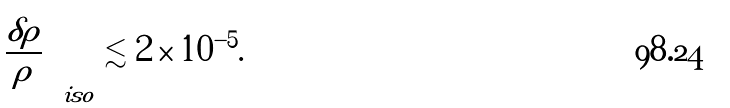<formula> <loc_0><loc_0><loc_500><loc_500>\left ( \frac { \delta \rho } { \rho } \right ) _ { i s o } \lesssim 2 \times 1 0 ^ { - 5 } .</formula> 